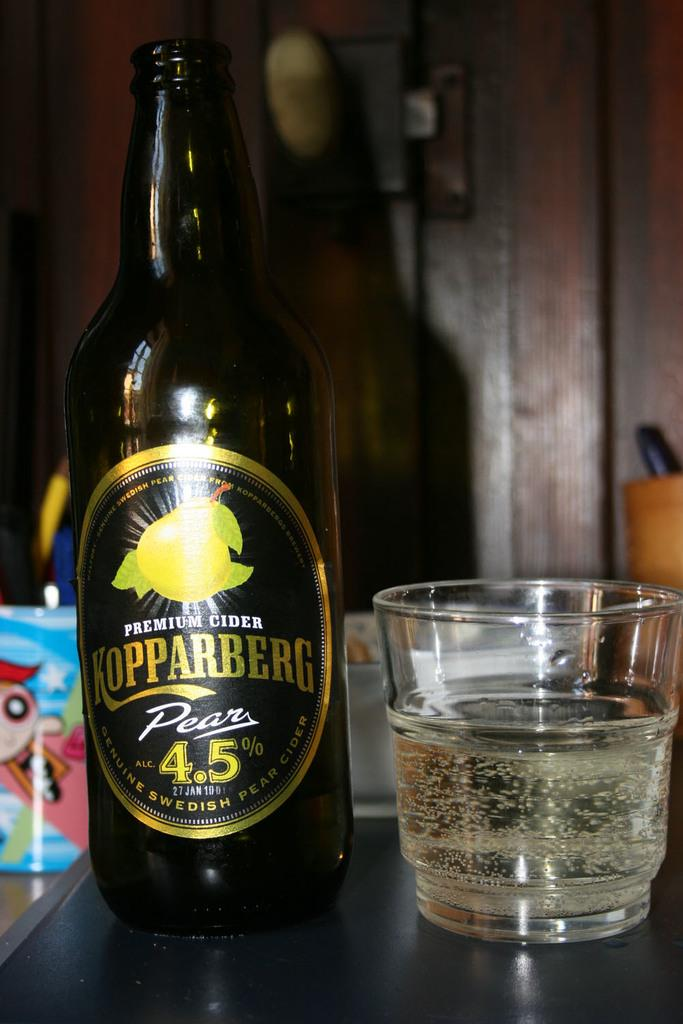<image>
Describe the image concisely. A bottle of liquid titled Kopparberg Pear next to a glass. 